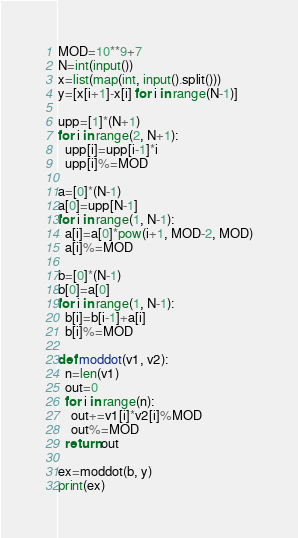<code> <loc_0><loc_0><loc_500><loc_500><_Python_>MOD=10**9+7
N=int(input())
x=list(map(int, input().split()))
y=[x[i+1]-x[i] for i in range(N-1)]
 
upp=[1]*(N+1)
for i in range(2, N+1):
  upp[i]=upp[i-1]*i
  upp[i]%=MOD
  
a=[0]*(N-1)
a[0]=upp[N-1]
for i in range(1, N-1):
  a[i]=a[0]*pow(i+1, MOD-2, MOD)
  a[i]%=MOD

b=[0]*(N-1)
b[0]=a[0]
for i in range(1, N-1):
  b[i]=b[i-1]+a[i]
  b[i]%=MOD
  
def moddot(v1, v2):
  n=len(v1)
  out=0
  for i in range(n):
    out+=v1[i]*v2[i]%MOD
    out%=MOD
  return out
 
ex=moddot(b, y)
print(ex)</code> 